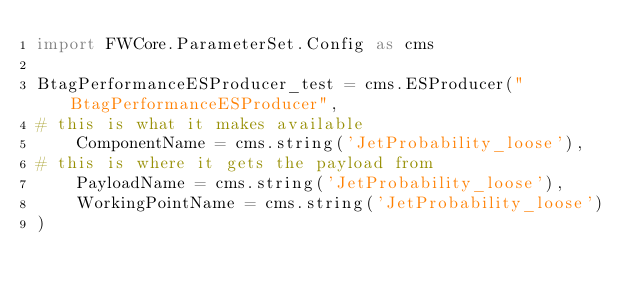<code> <loc_0><loc_0><loc_500><loc_500><_Python_>import FWCore.ParameterSet.Config as cms

BtagPerformanceESProducer_test = cms.ESProducer("BtagPerformanceESProducer",
# this is what it makes available
    ComponentName = cms.string('JetProbability_loose'),
# this is where it gets the payload from                                                
    PayloadName = cms.string('JetProbability_loose'),
    WorkingPointName = cms.string('JetProbability_loose')
)


</code> 